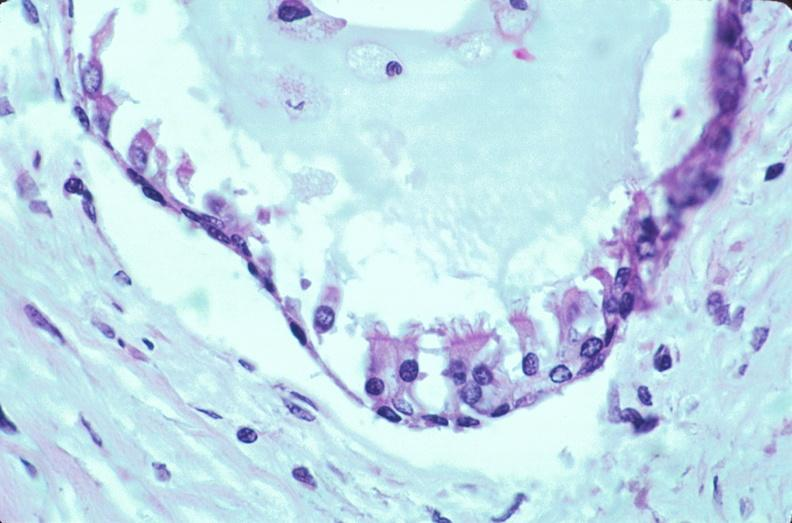what is embryo-fetus?
Answer the question using a single word or phrase. Fetus present 